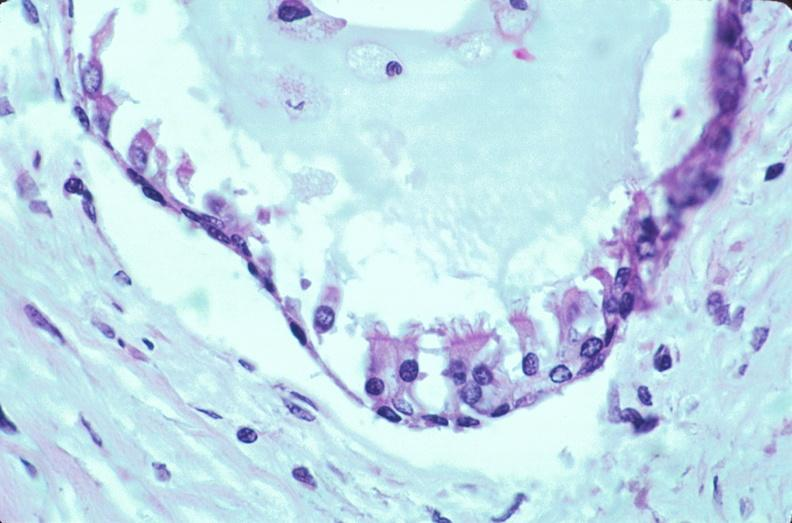what is embryo-fetus?
Answer the question using a single word or phrase. Fetus present 